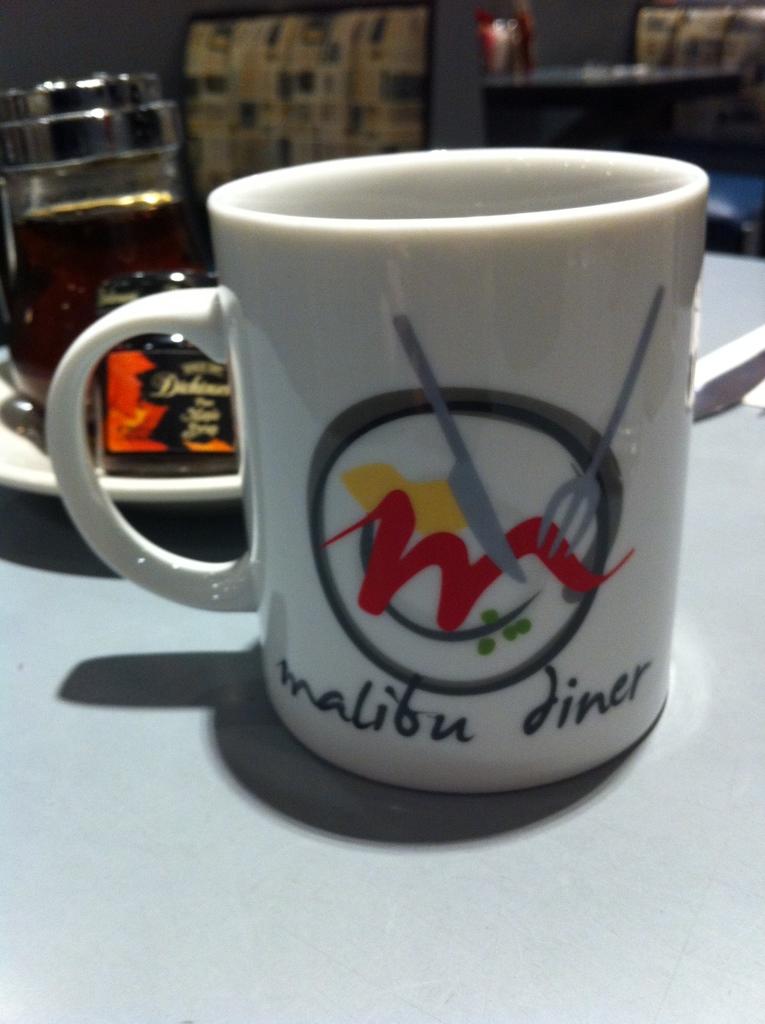Where was this cup purchased?
Provide a succinct answer. Malibu diner. What type of establishment is advertised on the mug?
Give a very brief answer. Diner. 